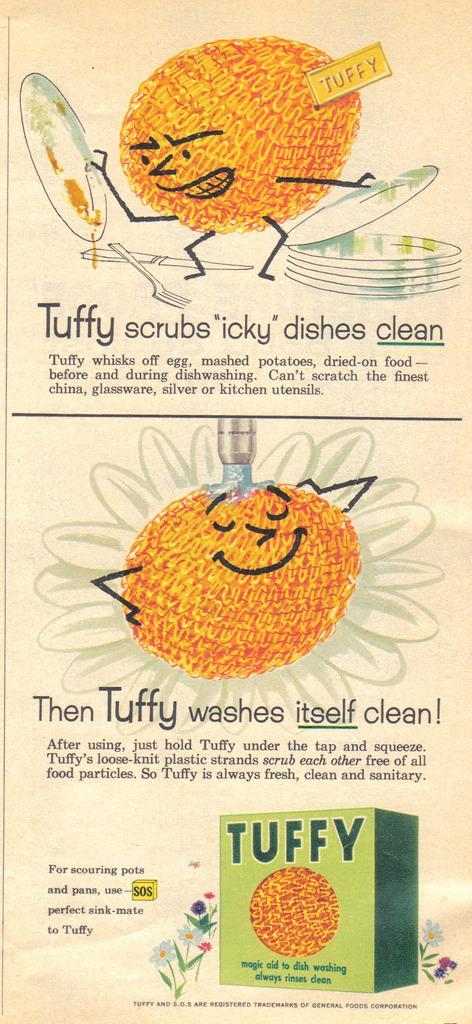Could you give a brief overview of what you see in this image? In this image I can see few cartoon characters and I can also see something is written. On the bottom side of this image I can see a green colour thing. 